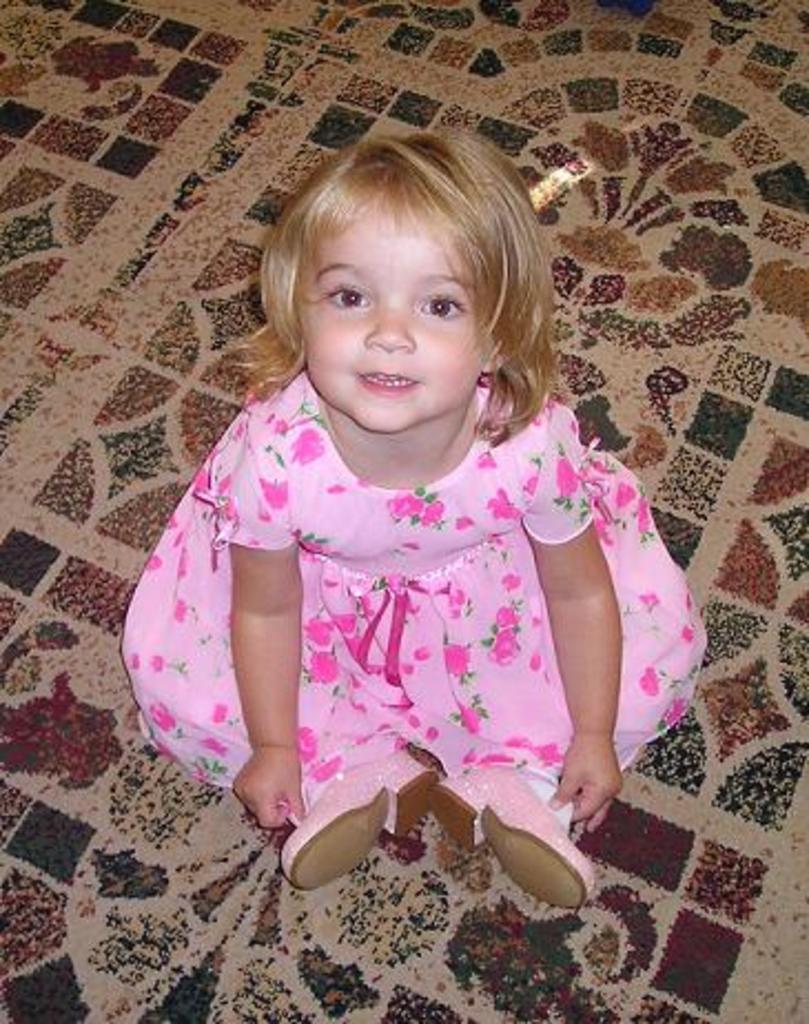Can you describe this image briefly? In this picture we can see a kid sitting on the floor, she wore a pink color dress and shoes. 